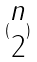<formula> <loc_0><loc_0><loc_500><loc_500>( \begin{matrix} n \\ 2 \end{matrix} )</formula> 